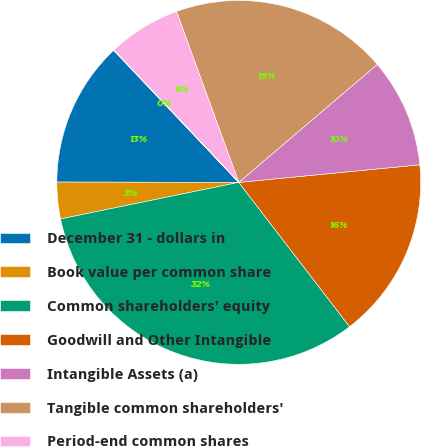Convert chart. <chart><loc_0><loc_0><loc_500><loc_500><pie_chart><fcel>December 31 - dollars in<fcel>Book value per common share<fcel>Common shareholders' equity<fcel>Goodwill and Other Intangible<fcel>Intangible Assets (a)<fcel>Tangible common shareholders'<fcel>Period-end common shares<fcel>Tangible book value per common<nl><fcel>12.9%<fcel>3.25%<fcel>32.2%<fcel>16.12%<fcel>9.69%<fcel>19.33%<fcel>6.47%<fcel>0.04%<nl></chart> 